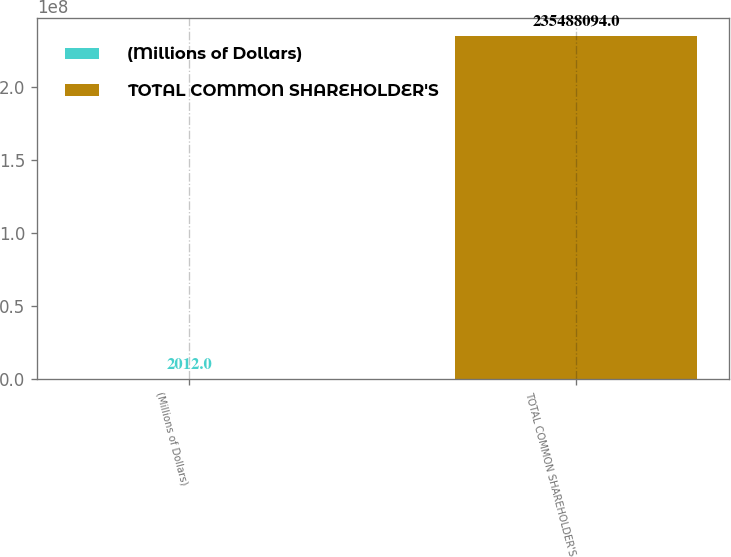Convert chart to OTSL. <chart><loc_0><loc_0><loc_500><loc_500><bar_chart><fcel>(Millions of Dollars)<fcel>TOTAL COMMON SHAREHOLDER'S<nl><fcel>2012<fcel>2.35488e+08<nl></chart> 